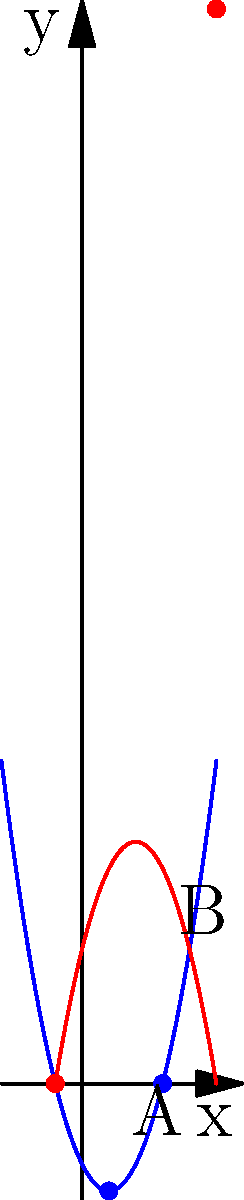In a debate on economic policies, you're presenting data on two different economic models represented by quadratic functions. Model A is given by $f(x) = x^2 - 2x - 3$, and Model B is given by $g(x) = -x^2 + 4x + 5$. At which points do these models intersect, and what is the sum of the x-coordinates of these intersection points? To find the intersection points, we need to solve the equation $f(x) = g(x)$:

1) Set up the equation:
   $x^2 - 2x - 3 = -x^2 + 4x + 5$

2) Rearrange to standard form:
   $2x^2 - 6x - 8 = 0$

3) Simplify:
   $x^2 - 3x - 4 = 0$

4) Use the quadratic formula: $x = \frac{-b \pm \sqrt{b^2 - 4ac}}{2a}$
   Where $a=1$, $b=-3$, and $c=-4$

5) Substitute into the formula:
   $x = \frac{3 \pm \sqrt{(-3)^2 - 4(1)(-4)}}{2(1)} = \frac{3 \pm \sqrt{9 + 16}}{2} = \frac{3 \pm \sqrt{25}}{2} = \frac{3 \pm 5}{2}$

6) Solve:
   $x_1 = \frac{3 + 5}{2} = 4$ and $x_2 = \frac{3 - 5}{2} = -1$

7) The intersection points are at $x = 4$ and $x = -1$

8) Sum of x-coordinates: $4 + (-1) = 3$

Therefore, the models intersect at two points with x-coordinates 4 and -1, and their sum is 3.
Answer: 3 